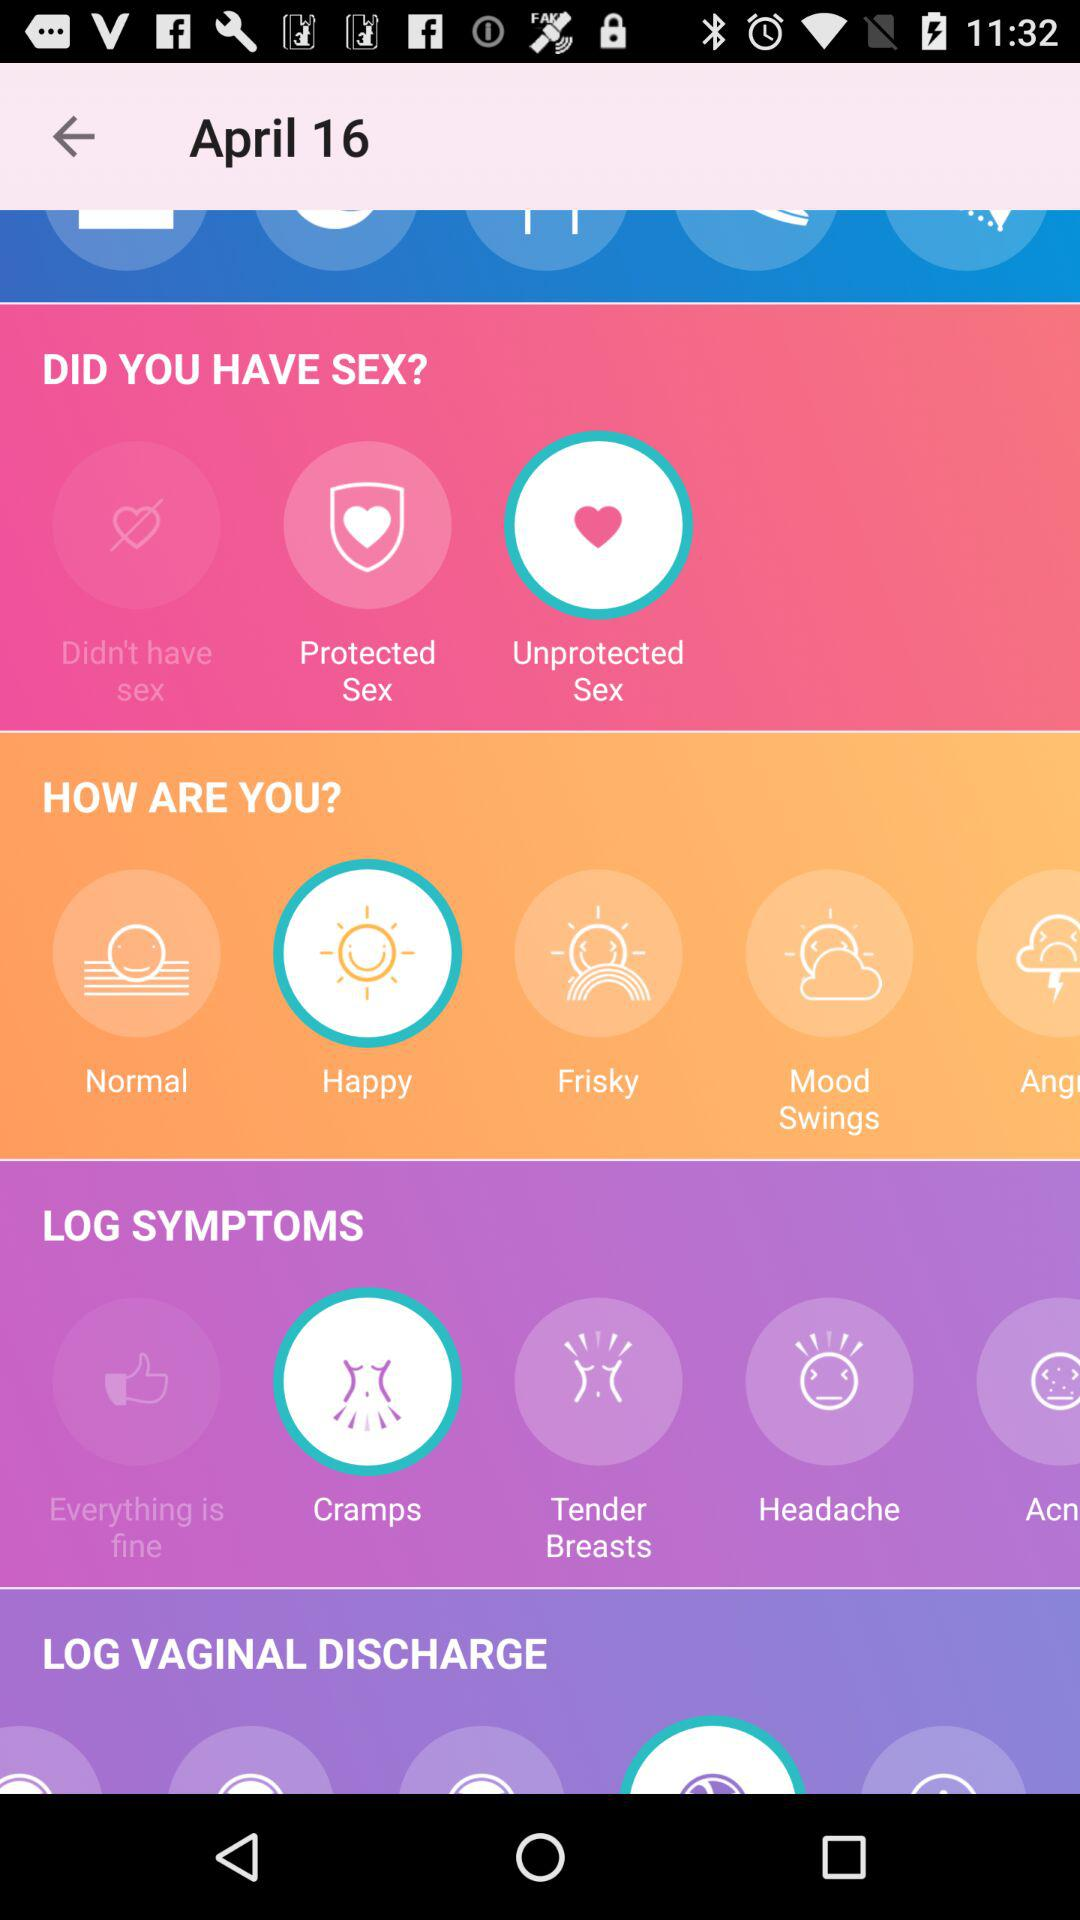What option is selected in "DID YOU HAVE SEX"? The selected option is "Unprotected Sex". 